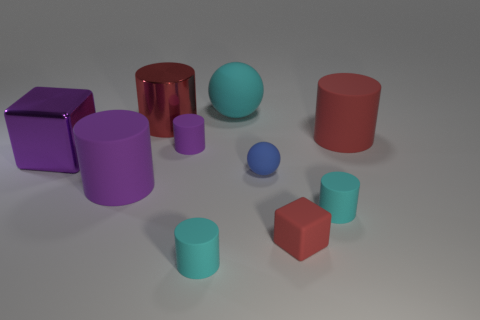Subtract all large red metallic cylinders. How many cylinders are left? 5 Subtract 2 cylinders. How many cylinders are left? 4 Subtract all red cylinders. How many cylinders are left? 4 Subtract all yellow cylinders. Subtract all gray blocks. How many cylinders are left? 6 Subtract all spheres. How many objects are left? 8 Subtract all large matte objects. Subtract all big metallic things. How many objects are left? 5 Add 2 large purple cylinders. How many large purple cylinders are left? 3 Add 8 large purple matte balls. How many large purple matte balls exist? 8 Subtract 0 brown cylinders. How many objects are left? 10 